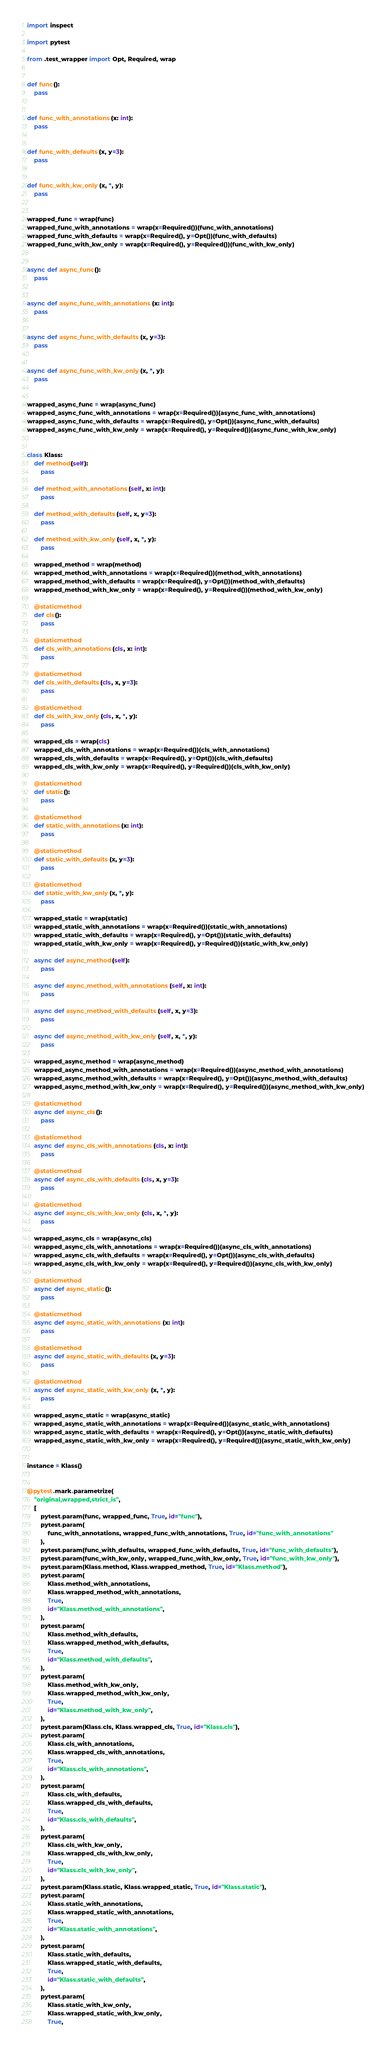<code> <loc_0><loc_0><loc_500><loc_500><_Python_>import inspect

import pytest

from .test_wrapper import Opt, Required, wrap


def func():
    pass


def func_with_annotations(x: int):
    pass


def func_with_defaults(x, y=3):
    pass


def func_with_kw_only(x, *, y):
    pass


wrapped_func = wrap(func)
wrapped_func_with_annotations = wrap(x=Required())(func_with_annotations)
wrapped_func_with_defaults = wrap(x=Required(), y=Opt())(func_with_defaults)
wrapped_func_with_kw_only = wrap(x=Required(), y=Required())(func_with_kw_only)


async def async_func():
    pass


async def async_func_with_annotations(x: int):
    pass


async def async_func_with_defaults(x, y=3):
    pass


async def async_func_with_kw_only(x, *, y):
    pass


wrapped_async_func = wrap(async_func)
wrapped_async_func_with_annotations = wrap(x=Required())(async_func_with_annotations)
wrapped_async_func_with_defaults = wrap(x=Required(), y=Opt())(async_func_with_defaults)
wrapped_async_func_with_kw_only = wrap(x=Required(), y=Required())(async_func_with_kw_only)


class Klass:
    def method(self):
        pass

    def method_with_annotations(self, x: int):
        pass

    def method_with_defaults(self, x, y=3):
        pass

    def method_with_kw_only(self, x, *, y):
        pass

    wrapped_method = wrap(method)
    wrapped_method_with_annotations = wrap(x=Required())(method_with_annotations)
    wrapped_method_with_defaults = wrap(x=Required(), y=Opt())(method_with_defaults)
    wrapped_method_with_kw_only = wrap(x=Required(), y=Required())(method_with_kw_only)

    @staticmethod
    def cls():
        pass

    @staticmethod
    def cls_with_annotations(cls, x: int):
        pass

    @staticmethod
    def cls_with_defaults(cls, x, y=3):
        pass

    @staticmethod
    def cls_with_kw_only(cls, x, *, y):
        pass

    wrapped_cls = wrap(cls)
    wrapped_cls_with_annotations = wrap(x=Required())(cls_with_annotations)
    wrapped_cls_with_defaults = wrap(x=Required(), y=Opt())(cls_with_defaults)
    wrapped_cls_with_kw_only = wrap(x=Required(), y=Required())(cls_with_kw_only)

    @staticmethod
    def static():
        pass

    @staticmethod
    def static_with_annotations(x: int):
        pass

    @staticmethod
    def static_with_defaults(x, y=3):
        pass

    @staticmethod
    def static_with_kw_only(x, *, y):
        pass

    wrapped_static = wrap(static)
    wrapped_static_with_annotations = wrap(x=Required())(static_with_annotations)
    wrapped_static_with_defaults = wrap(x=Required(), y=Opt())(static_with_defaults)
    wrapped_static_with_kw_only = wrap(x=Required(), y=Required())(static_with_kw_only)

    async def async_method(self):
        pass

    async def async_method_with_annotations(self, x: int):
        pass

    async def async_method_with_defaults(self, x, y=3):
        pass

    async def async_method_with_kw_only(self, x, *, y):
        pass

    wrapped_async_method = wrap(async_method)
    wrapped_async_method_with_annotations = wrap(x=Required())(async_method_with_annotations)
    wrapped_async_method_with_defaults = wrap(x=Required(), y=Opt())(async_method_with_defaults)
    wrapped_async_method_with_kw_only = wrap(x=Required(), y=Required())(async_method_with_kw_only)

    @staticmethod
    async def async_cls():
        pass

    @staticmethod
    async def async_cls_with_annotations(cls, x: int):
        pass

    @staticmethod
    async def async_cls_with_defaults(cls, x, y=3):
        pass

    @staticmethod
    async def async_cls_with_kw_only(cls, x, *, y):
        pass

    wrapped_async_cls = wrap(async_cls)
    wrapped_async_cls_with_annotations = wrap(x=Required())(async_cls_with_annotations)
    wrapped_async_cls_with_defaults = wrap(x=Required(), y=Opt())(async_cls_with_defaults)
    wrapped_async_cls_with_kw_only = wrap(x=Required(), y=Required())(async_cls_with_kw_only)

    @staticmethod
    async def async_static():
        pass

    @staticmethod
    async def async_static_with_annotations(x: int):
        pass

    @staticmethod
    async def async_static_with_defaults(x, y=3):
        pass

    @staticmethod
    async def async_static_with_kw_only(x, *, y):
        pass

    wrapped_async_static = wrap(async_static)
    wrapped_async_static_with_annotations = wrap(x=Required())(async_static_with_annotations)
    wrapped_async_static_with_defaults = wrap(x=Required(), y=Opt())(async_static_with_defaults)
    wrapped_async_static_with_kw_only = wrap(x=Required(), y=Required())(async_static_with_kw_only)


instance = Klass()


@pytest.mark.parametrize(
    "original,wrapped,strict_is",
    [
        pytest.param(func, wrapped_func, True, id="func"),
        pytest.param(
            func_with_annotations, wrapped_func_with_annotations, True, id="func_with_annotations"
        ),
        pytest.param(func_with_defaults, wrapped_func_with_defaults, True, id="func_with_defaults"),
        pytest.param(func_with_kw_only, wrapped_func_with_kw_only, True, id="func_with_kw_only"),
        pytest.param(Klass.method, Klass.wrapped_method, True, id="Klass.method"),
        pytest.param(
            Klass.method_with_annotations,
            Klass.wrapped_method_with_annotations,
            True,
            id="Klass.method_with_annotations",
        ),
        pytest.param(
            Klass.method_with_defaults,
            Klass.wrapped_method_with_defaults,
            True,
            id="Klass.method_with_defaults",
        ),
        pytest.param(
            Klass.method_with_kw_only,
            Klass.wrapped_method_with_kw_only,
            True,
            id="Klass.method_with_kw_only",
        ),
        pytest.param(Klass.cls, Klass.wrapped_cls, True, id="Klass.cls"),
        pytest.param(
            Klass.cls_with_annotations,
            Klass.wrapped_cls_with_annotations,
            True,
            id="Klass.cls_with_annotations",
        ),
        pytest.param(
            Klass.cls_with_defaults,
            Klass.wrapped_cls_with_defaults,
            True,
            id="Klass.cls_with_defaults",
        ),
        pytest.param(
            Klass.cls_with_kw_only,
            Klass.wrapped_cls_with_kw_only,
            True,
            id="Klass.cls_with_kw_only",
        ),
        pytest.param(Klass.static, Klass.wrapped_static, True, id="Klass.static"),
        pytest.param(
            Klass.static_with_annotations,
            Klass.wrapped_static_with_annotations,
            True,
            id="Klass.static_with_annotations",
        ),
        pytest.param(
            Klass.static_with_defaults,
            Klass.wrapped_static_with_defaults,
            True,
            id="Klass.static_with_defaults",
        ),
        pytest.param(
            Klass.static_with_kw_only,
            Klass.wrapped_static_with_kw_only,
            True,</code> 